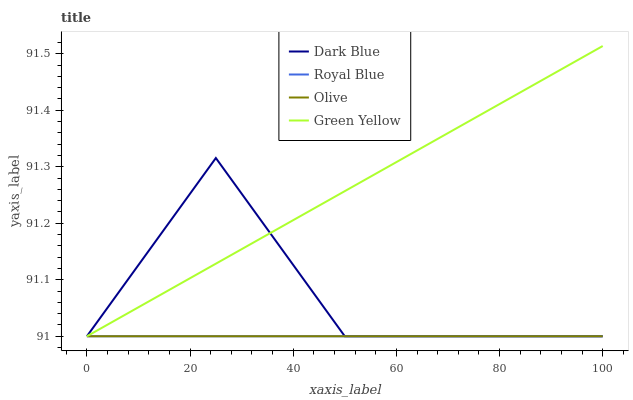Does Olive have the minimum area under the curve?
Answer yes or no. Yes. Does Green Yellow have the maximum area under the curve?
Answer yes or no. Yes. Does Dark Blue have the minimum area under the curve?
Answer yes or no. No. Does Dark Blue have the maximum area under the curve?
Answer yes or no. No. Is Olive the smoothest?
Answer yes or no. Yes. Is Dark Blue the roughest?
Answer yes or no. Yes. Is Dark Blue the smoothest?
Answer yes or no. No. Is Green Yellow the roughest?
Answer yes or no. No. Does Olive have the lowest value?
Answer yes or no. Yes. Does Green Yellow have the highest value?
Answer yes or no. Yes. Does Dark Blue have the highest value?
Answer yes or no. No. Does Dark Blue intersect Green Yellow?
Answer yes or no. Yes. Is Dark Blue less than Green Yellow?
Answer yes or no. No. Is Dark Blue greater than Green Yellow?
Answer yes or no. No. 